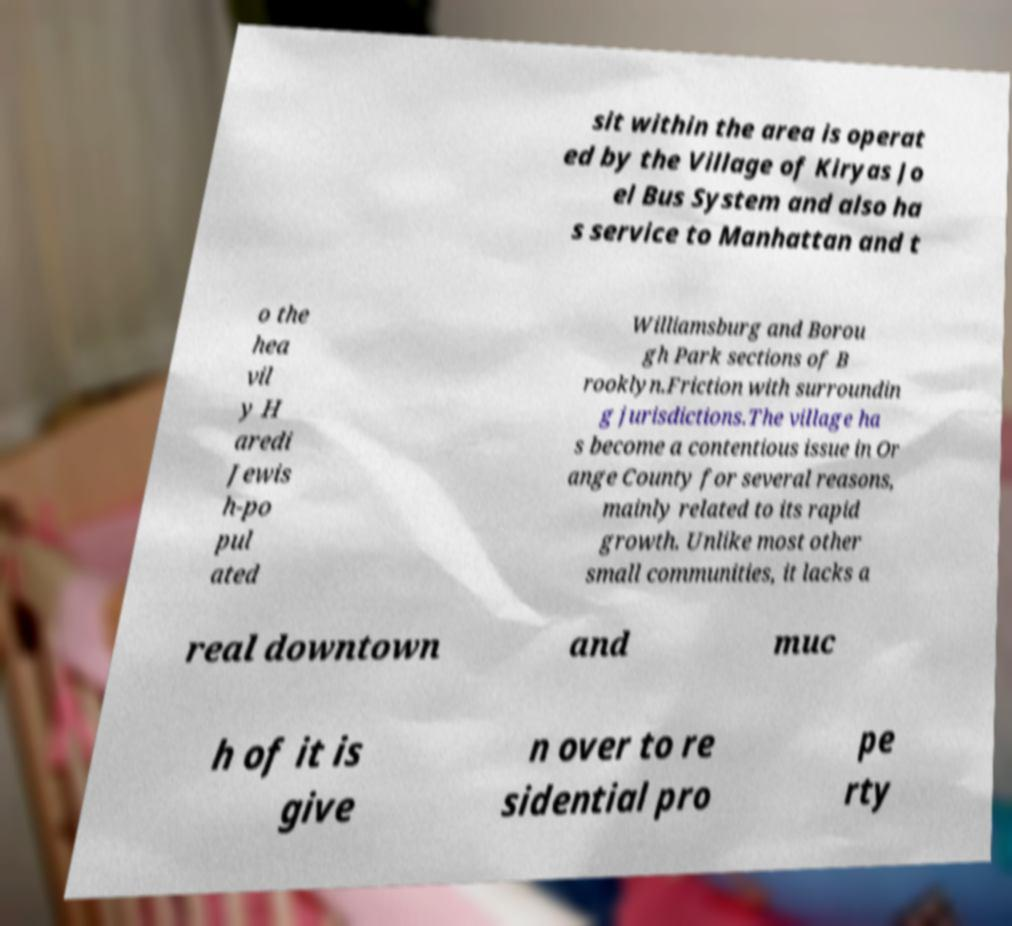What messages or text are displayed in this image? I need them in a readable, typed format. sit within the area is operat ed by the Village of Kiryas Jo el Bus System and also ha s service to Manhattan and t o the hea vil y H aredi Jewis h-po pul ated Williamsburg and Borou gh Park sections of B rooklyn.Friction with surroundin g jurisdictions.The village ha s become a contentious issue in Or ange County for several reasons, mainly related to its rapid growth. Unlike most other small communities, it lacks a real downtown and muc h of it is give n over to re sidential pro pe rty 